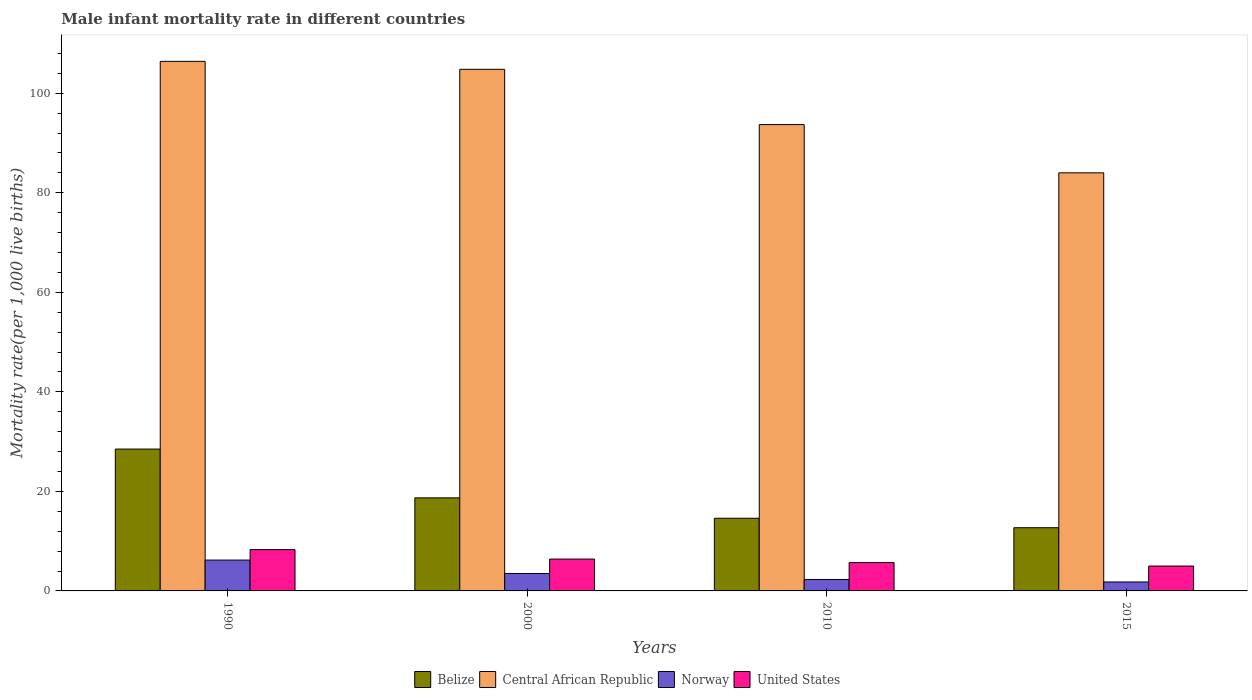How many different coloured bars are there?
Make the answer very short. 4. In how many cases, is the number of bars for a given year not equal to the number of legend labels?
Provide a short and direct response. 0. Across all years, what is the minimum male infant mortality rate in Norway?
Offer a terse response. 1.8. In which year was the male infant mortality rate in Central African Republic minimum?
Provide a short and direct response. 2015. What is the total male infant mortality rate in United States in the graph?
Provide a short and direct response. 25.4. What is the difference between the male infant mortality rate in United States in 2010 and that in 2015?
Provide a short and direct response. 0.7. What is the difference between the male infant mortality rate in Central African Republic in 2010 and the male infant mortality rate in Belize in 1990?
Give a very brief answer. 65.2. What is the average male infant mortality rate in Belize per year?
Make the answer very short. 18.62. In the year 2010, what is the difference between the male infant mortality rate in Belize and male infant mortality rate in Central African Republic?
Offer a terse response. -79.1. What is the ratio of the male infant mortality rate in Norway in 2000 to that in 2010?
Keep it short and to the point. 1.52. Is the difference between the male infant mortality rate in Belize in 2010 and 2015 greater than the difference between the male infant mortality rate in Central African Republic in 2010 and 2015?
Offer a terse response. No. What is the difference between the highest and the second highest male infant mortality rate in Norway?
Offer a terse response. 2.7. What is the difference between the highest and the lowest male infant mortality rate in United States?
Ensure brevity in your answer.  3.3. Is it the case that in every year, the sum of the male infant mortality rate in United States and male infant mortality rate in Belize is greater than the sum of male infant mortality rate in Central African Republic and male infant mortality rate in Norway?
Keep it short and to the point. No. Is it the case that in every year, the sum of the male infant mortality rate in United States and male infant mortality rate in Belize is greater than the male infant mortality rate in Norway?
Your response must be concise. Yes. Are the values on the major ticks of Y-axis written in scientific E-notation?
Keep it short and to the point. No. Where does the legend appear in the graph?
Make the answer very short. Bottom center. What is the title of the graph?
Provide a short and direct response. Male infant mortality rate in different countries. What is the label or title of the Y-axis?
Provide a succinct answer. Mortality rate(per 1,0 live births). What is the Mortality rate(per 1,000 live births) in Central African Republic in 1990?
Provide a succinct answer. 106.4. What is the Mortality rate(per 1,000 live births) in Belize in 2000?
Offer a very short reply. 18.7. What is the Mortality rate(per 1,000 live births) of Central African Republic in 2000?
Give a very brief answer. 104.8. What is the Mortality rate(per 1,000 live births) of Norway in 2000?
Your answer should be very brief. 3.5. What is the Mortality rate(per 1,000 live births) in Central African Republic in 2010?
Your answer should be very brief. 93.7. What is the Mortality rate(per 1,000 live births) in Norway in 2010?
Provide a succinct answer. 2.3. What is the Mortality rate(per 1,000 live births) in Central African Republic in 2015?
Keep it short and to the point. 84. Across all years, what is the maximum Mortality rate(per 1,000 live births) in Belize?
Give a very brief answer. 28.5. Across all years, what is the maximum Mortality rate(per 1,000 live births) of Central African Republic?
Keep it short and to the point. 106.4. Across all years, what is the maximum Mortality rate(per 1,000 live births) in United States?
Ensure brevity in your answer.  8.3. Across all years, what is the minimum Mortality rate(per 1,000 live births) in Belize?
Keep it short and to the point. 12.7. Across all years, what is the minimum Mortality rate(per 1,000 live births) in United States?
Keep it short and to the point. 5. What is the total Mortality rate(per 1,000 live births) of Belize in the graph?
Your response must be concise. 74.5. What is the total Mortality rate(per 1,000 live births) in Central African Republic in the graph?
Provide a succinct answer. 388.9. What is the total Mortality rate(per 1,000 live births) in Norway in the graph?
Keep it short and to the point. 13.8. What is the total Mortality rate(per 1,000 live births) of United States in the graph?
Keep it short and to the point. 25.4. What is the difference between the Mortality rate(per 1,000 live births) of Central African Republic in 1990 and that in 2000?
Keep it short and to the point. 1.6. What is the difference between the Mortality rate(per 1,000 live births) in Norway in 1990 and that in 2000?
Provide a succinct answer. 2.7. What is the difference between the Mortality rate(per 1,000 live births) in United States in 1990 and that in 2010?
Offer a terse response. 2.6. What is the difference between the Mortality rate(per 1,000 live births) in Belize in 1990 and that in 2015?
Give a very brief answer. 15.8. What is the difference between the Mortality rate(per 1,000 live births) of Central African Republic in 1990 and that in 2015?
Your answer should be very brief. 22.4. What is the difference between the Mortality rate(per 1,000 live births) of Norway in 1990 and that in 2015?
Ensure brevity in your answer.  4.4. What is the difference between the Mortality rate(per 1,000 live births) of Belize in 2000 and that in 2010?
Give a very brief answer. 4.1. What is the difference between the Mortality rate(per 1,000 live births) in Central African Republic in 2000 and that in 2010?
Make the answer very short. 11.1. What is the difference between the Mortality rate(per 1,000 live births) of United States in 2000 and that in 2010?
Your answer should be compact. 0.7. What is the difference between the Mortality rate(per 1,000 live births) in Belize in 2000 and that in 2015?
Provide a succinct answer. 6. What is the difference between the Mortality rate(per 1,000 live births) in Central African Republic in 2000 and that in 2015?
Ensure brevity in your answer.  20.8. What is the difference between the Mortality rate(per 1,000 live births) in Norway in 2010 and that in 2015?
Provide a succinct answer. 0.5. What is the difference between the Mortality rate(per 1,000 live births) in United States in 2010 and that in 2015?
Provide a succinct answer. 0.7. What is the difference between the Mortality rate(per 1,000 live births) of Belize in 1990 and the Mortality rate(per 1,000 live births) of Central African Republic in 2000?
Offer a terse response. -76.3. What is the difference between the Mortality rate(per 1,000 live births) in Belize in 1990 and the Mortality rate(per 1,000 live births) in United States in 2000?
Provide a succinct answer. 22.1. What is the difference between the Mortality rate(per 1,000 live births) in Central African Republic in 1990 and the Mortality rate(per 1,000 live births) in Norway in 2000?
Give a very brief answer. 102.9. What is the difference between the Mortality rate(per 1,000 live births) in Belize in 1990 and the Mortality rate(per 1,000 live births) in Central African Republic in 2010?
Give a very brief answer. -65.2. What is the difference between the Mortality rate(per 1,000 live births) in Belize in 1990 and the Mortality rate(per 1,000 live births) in Norway in 2010?
Offer a terse response. 26.2. What is the difference between the Mortality rate(per 1,000 live births) in Belize in 1990 and the Mortality rate(per 1,000 live births) in United States in 2010?
Ensure brevity in your answer.  22.8. What is the difference between the Mortality rate(per 1,000 live births) in Central African Republic in 1990 and the Mortality rate(per 1,000 live births) in Norway in 2010?
Your response must be concise. 104.1. What is the difference between the Mortality rate(per 1,000 live births) in Central African Republic in 1990 and the Mortality rate(per 1,000 live births) in United States in 2010?
Your response must be concise. 100.7. What is the difference between the Mortality rate(per 1,000 live births) in Norway in 1990 and the Mortality rate(per 1,000 live births) in United States in 2010?
Your answer should be compact. 0.5. What is the difference between the Mortality rate(per 1,000 live births) in Belize in 1990 and the Mortality rate(per 1,000 live births) in Central African Republic in 2015?
Offer a very short reply. -55.5. What is the difference between the Mortality rate(per 1,000 live births) of Belize in 1990 and the Mortality rate(per 1,000 live births) of Norway in 2015?
Offer a very short reply. 26.7. What is the difference between the Mortality rate(per 1,000 live births) in Belize in 1990 and the Mortality rate(per 1,000 live births) in United States in 2015?
Your answer should be very brief. 23.5. What is the difference between the Mortality rate(per 1,000 live births) of Central African Republic in 1990 and the Mortality rate(per 1,000 live births) of Norway in 2015?
Offer a terse response. 104.6. What is the difference between the Mortality rate(per 1,000 live births) of Central African Republic in 1990 and the Mortality rate(per 1,000 live births) of United States in 2015?
Your answer should be compact. 101.4. What is the difference between the Mortality rate(per 1,000 live births) of Norway in 1990 and the Mortality rate(per 1,000 live births) of United States in 2015?
Ensure brevity in your answer.  1.2. What is the difference between the Mortality rate(per 1,000 live births) in Belize in 2000 and the Mortality rate(per 1,000 live births) in Central African Republic in 2010?
Offer a very short reply. -75. What is the difference between the Mortality rate(per 1,000 live births) in Belize in 2000 and the Mortality rate(per 1,000 live births) in Norway in 2010?
Your response must be concise. 16.4. What is the difference between the Mortality rate(per 1,000 live births) of Belize in 2000 and the Mortality rate(per 1,000 live births) of United States in 2010?
Give a very brief answer. 13. What is the difference between the Mortality rate(per 1,000 live births) in Central African Republic in 2000 and the Mortality rate(per 1,000 live births) in Norway in 2010?
Your answer should be very brief. 102.5. What is the difference between the Mortality rate(per 1,000 live births) in Central African Republic in 2000 and the Mortality rate(per 1,000 live births) in United States in 2010?
Your answer should be compact. 99.1. What is the difference between the Mortality rate(per 1,000 live births) of Norway in 2000 and the Mortality rate(per 1,000 live births) of United States in 2010?
Provide a short and direct response. -2.2. What is the difference between the Mortality rate(per 1,000 live births) in Belize in 2000 and the Mortality rate(per 1,000 live births) in Central African Republic in 2015?
Provide a succinct answer. -65.3. What is the difference between the Mortality rate(per 1,000 live births) of Belize in 2000 and the Mortality rate(per 1,000 live births) of United States in 2015?
Keep it short and to the point. 13.7. What is the difference between the Mortality rate(per 1,000 live births) in Central African Republic in 2000 and the Mortality rate(per 1,000 live births) in Norway in 2015?
Make the answer very short. 103. What is the difference between the Mortality rate(per 1,000 live births) in Central African Republic in 2000 and the Mortality rate(per 1,000 live births) in United States in 2015?
Keep it short and to the point. 99.8. What is the difference between the Mortality rate(per 1,000 live births) in Belize in 2010 and the Mortality rate(per 1,000 live births) in Central African Republic in 2015?
Offer a terse response. -69.4. What is the difference between the Mortality rate(per 1,000 live births) of Belize in 2010 and the Mortality rate(per 1,000 live births) of Norway in 2015?
Give a very brief answer. 12.8. What is the difference between the Mortality rate(per 1,000 live births) in Belize in 2010 and the Mortality rate(per 1,000 live births) in United States in 2015?
Provide a succinct answer. 9.6. What is the difference between the Mortality rate(per 1,000 live births) in Central African Republic in 2010 and the Mortality rate(per 1,000 live births) in Norway in 2015?
Offer a very short reply. 91.9. What is the difference between the Mortality rate(per 1,000 live births) in Central African Republic in 2010 and the Mortality rate(per 1,000 live births) in United States in 2015?
Give a very brief answer. 88.7. What is the difference between the Mortality rate(per 1,000 live births) in Norway in 2010 and the Mortality rate(per 1,000 live births) in United States in 2015?
Make the answer very short. -2.7. What is the average Mortality rate(per 1,000 live births) in Belize per year?
Keep it short and to the point. 18.62. What is the average Mortality rate(per 1,000 live births) of Central African Republic per year?
Make the answer very short. 97.22. What is the average Mortality rate(per 1,000 live births) in Norway per year?
Ensure brevity in your answer.  3.45. What is the average Mortality rate(per 1,000 live births) of United States per year?
Ensure brevity in your answer.  6.35. In the year 1990, what is the difference between the Mortality rate(per 1,000 live births) in Belize and Mortality rate(per 1,000 live births) in Central African Republic?
Ensure brevity in your answer.  -77.9. In the year 1990, what is the difference between the Mortality rate(per 1,000 live births) of Belize and Mortality rate(per 1,000 live births) of Norway?
Your answer should be very brief. 22.3. In the year 1990, what is the difference between the Mortality rate(per 1,000 live births) in Belize and Mortality rate(per 1,000 live births) in United States?
Keep it short and to the point. 20.2. In the year 1990, what is the difference between the Mortality rate(per 1,000 live births) in Central African Republic and Mortality rate(per 1,000 live births) in Norway?
Offer a terse response. 100.2. In the year 1990, what is the difference between the Mortality rate(per 1,000 live births) in Central African Republic and Mortality rate(per 1,000 live births) in United States?
Offer a very short reply. 98.1. In the year 1990, what is the difference between the Mortality rate(per 1,000 live births) in Norway and Mortality rate(per 1,000 live births) in United States?
Your answer should be very brief. -2.1. In the year 2000, what is the difference between the Mortality rate(per 1,000 live births) in Belize and Mortality rate(per 1,000 live births) in Central African Republic?
Offer a very short reply. -86.1. In the year 2000, what is the difference between the Mortality rate(per 1,000 live births) of Belize and Mortality rate(per 1,000 live births) of Norway?
Your answer should be very brief. 15.2. In the year 2000, what is the difference between the Mortality rate(per 1,000 live births) of Central African Republic and Mortality rate(per 1,000 live births) of Norway?
Offer a very short reply. 101.3. In the year 2000, what is the difference between the Mortality rate(per 1,000 live births) in Central African Republic and Mortality rate(per 1,000 live births) in United States?
Give a very brief answer. 98.4. In the year 2010, what is the difference between the Mortality rate(per 1,000 live births) of Belize and Mortality rate(per 1,000 live births) of Central African Republic?
Ensure brevity in your answer.  -79.1. In the year 2010, what is the difference between the Mortality rate(per 1,000 live births) in Belize and Mortality rate(per 1,000 live births) in Norway?
Keep it short and to the point. 12.3. In the year 2010, what is the difference between the Mortality rate(per 1,000 live births) of Belize and Mortality rate(per 1,000 live births) of United States?
Give a very brief answer. 8.9. In the year 2010, what is the difference between the Mortality rate(per 1,000 live births) in Central African Republic and Mortality rate(per 1,000 live births) in Norway?
Offer a terse response. 91.4. In the year 2010, what is the difference between the Mortality rate(per 1,000 live births) in Central African Republic and Mortality rate(per 1,000 live births) in United States?
Offer a terse response. 88. In the year 2010, what is the difference between the Mortality rate(per 1,000 live births) of Norway and Mortality rate(per 1,000 live births) of United States?
Ensure brevity in your answer.  -3.4. In the year 2015, what is the difference between the Mortality rate(per 1,000 live births) of Belize and Mortality rate(per 1,000 live births) of Central African Republic?
Provide a succinct answer. -71.3. In the year 2015, what is the difference between the Mortality rate(per 1,000 live births) of Belize and Mortality rate(per 1,000 live births) of Norway?
Offer a very short reply. 10.9. In the year 2015, what is the difference between the Mortality rate(per 1,000 live births) in Central African Republic and Mortality rate(per 1,000 live births) in Norway?
Offer a terse response. 82.2. In the year 2015, what is the difference between the Mortality rate(per 1,000 live births) of Central African Republic and Mortality rate(per 1,000 live births) of United States?
Your answer should be very brief. 79. In the year 2015, what is the difference between the Mortality rate(per 1,000 live births) of Norway and Mortality rate(per 1,000 live births) of United States?
Ensure brevity in your answer.  -3.2. What is the ratio of the Mortality rate(per 1,000 live births) of Belize in 1990 to that in 2000?
Your answer should be very brief. 1.52. What is the ratio of the Mortality rate(per 1,000 live births) of Central African Republic in 1990 to that in 2000?
Offer a very short reply. 1.02. What is the ratio of the Mortality rate(per 1,000 live births) of Norway in 1990 to that in 2000?
Make the answer very short. 1.77. What is the ratio of the Mortality rate(per 1,000 live births) of United States in 1990 to that in 2000?
Offer a terse response. 1.3. What is the ratio of the Mortality rate(per 1,000 live births) in Belize in 1990 to that in 2010?
Provide a succinct answer. 1.95. What is the ratio of the Mortality rate(per 1,000 live births) in Central African Republic in 1990 to that in 2010?
Your answer should be compact. 1.14. What is the ratio of the Mortality rate(per 1,000 live births) of Norway in 1990 to that in 2010?
Your answer should be compact. 2.7. What is the ratio of the Mortality rate(per 1,000 live births) of United States in 1990 to that in 2010?
Your response must be concise. 1.46. What is the ratio of the Mortality rate(per 1,000 live births) of Belize in 1990 to that in 2015?
Offer a terse response. 2.24. What is the ratio of the Mortality rate(per 1,000 live births) in Central African Republic in 1990 to that in 2015?
Offer a very short reply. 1.27. What is the ratio of the Mortality rate(per 1,000 live births) in Norway in 1990 to that in 2015?
Provide a succinct answer. 3.44. What is the ratio of the Mortality rate(per 1,000 live births) in United States in 1990 to that in 2015?
Ensure brevity in your answer.  1.66. What is the ratio of the Mortality rate(per 1,000 live births) in Belize in 2000 to that in 2010?
Give a very brief answer. 1.28. What is the ratio of the Mortality rate(per 1,000 live births) in Central African Republic in 2000 to that in 2010?
Ensure brevity in your answer.  1.12. What is the ratio of the Mortality rate(per 1,000 live births) of Norway in 2000 to that in 2010?
Ensure brevity in your answer.  1.52. What is the ratio of the Mortality rate(per 1,000 live births) of United States in 2000 to that in 2010?
Your answer should be very brief. 1.12. What is the ratio of the Mortality rate(per 1,000 live births) in Belize in 2000 to that in 2015?
Offer a terse response. 1.47. What is the ratio of the Mortality rate(per 1,000 live births) in Central African Republic in 2000 to that in 2015?
Offer a terse response. 1.25. What is the ratio of the Mortality rate(per 1,000 live births) in Norway in 2000 to that in 2015?
Ensure brevity in your answer.  1.94. What is the ratio of the Mortality rate(per 1,000 live births) of United States in 2000 to that in 2015?
Your response must be concise. 1.28. What is the ratio of the Mortality rate(per 1,000 live births) of Belize in 2010 to that in 2015?
Provide a short and direct response. 1.15. What is the ratio of the Mortality rate(per 1,000 live births) in Central African Republic in 2010 to that in 2015?
Make the answer very short. 1.12. What is the ratio of the Mortality rate(per 1,000 live births) of Norway in 2010 to that in 2015?
Your answer should be very brief. 1.28. What is the ratio of the Mortality rate(per 1,000 live births) of United States in 2010 to that in 2015?
Provide a succinct answer. 1.14. What is the difference between the highest and the second highest Mortality rate(per 1,000 live births) of Belize?
Your response must be concise. 9.8. What is the difference between the highest and the second highest Mortality rate(per 1,000 live births) of Central African Republic?
Keep it short and to the point. 1.6. What is the difference between the highest and the second highest Mortality rate(per 1,000 live births) of United States?
Offer a terse response. 1.9. What is the difference between the highest and the lowest Mortality rate(per 1,000 live births) of Belize?
Provide a short and direct response. 15.8. What is the difference between the highest and the lowest Mortality rate(per 1,000 live births) of Central African Republic?
Your response must be concise. 22.4. What is the difference between the highest and the lowest Mortality rate(per 1,000 live births) in Norway?
Provide a succinct answer. 4.4. What is the difference between the highest and the lowest Mortality rate(per 1,000 live births) of United States?
Offer a terse response. 3.3. 